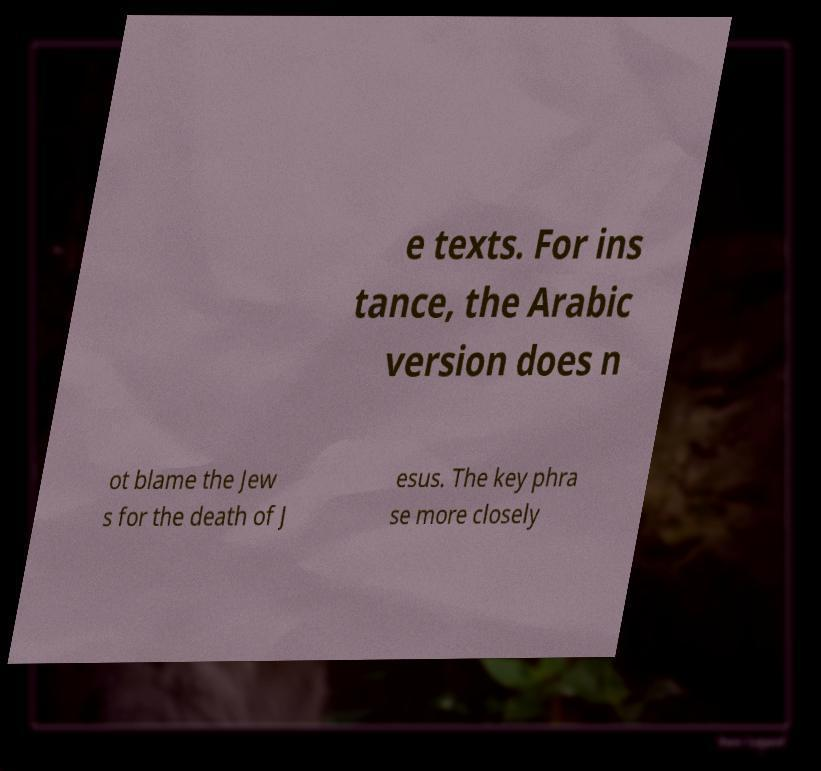What messages or text are displayed in this image? I need them in a readable, typed format. e texts. For ins tance, the Arabic version does n ot blame the Jew s for the death of J esus. The key phra se more closely 